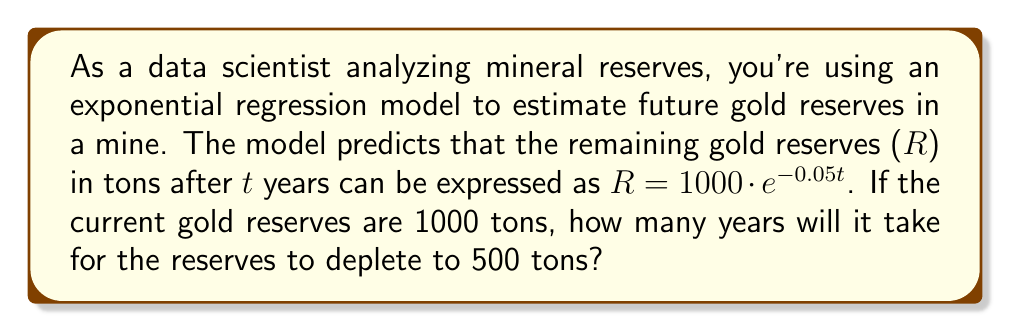Can you solve this math problem? To solve this problem, we need to use the given exponential model and solve for t when R = 500 tons. Let's approach this step-by-step:

1) The model is given as: $R = 1000 \cdot e^{-0.05t}$

2) We want to find t when R = 500 tons. So, let's substitute this:

   $500 = 1000 \cdot e^{-0.05t}$

3) Divide both sides by 1000:

   $\frac{500}{1000} = e^{-0.05t}$

4) Simplify:

   $0.5 = e^{-0.05t}$

5) Take the natural logarithm of both sides:

   $\ln(0.5) = \ln(e^{-0.05t})$

6) Simplify the right side using the properties of logarithms:

   $\ln(0.5) = -0.05t$

7) Divide both sides by -0.05:

   $\frac{\ln(0.5)}{-0.05} = t$

8) Calculate the value (you can use a calculator for this):

   $t \approx 13.86$ years

Therefore, it will take approximately 13.86 years for the gold reserves to deplete to 500 tons.
Answer: $13.86$ years 